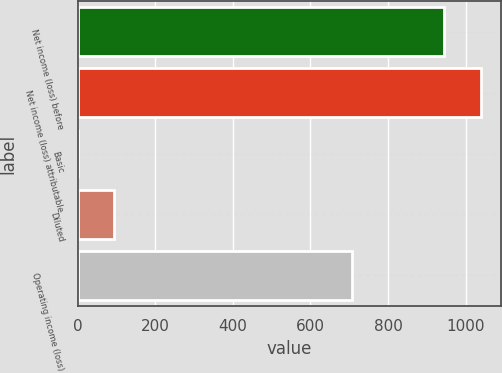<chart> <loc_0><loc_0><loc_500><loc_500><bar_chart><fcel>Net income (loss) before<fcel>Net income (loss) attributable<fcel>Basic<fcel>Diluted<fcel>Operating income (loss)<nl><fcel>945<fcel>1039.5<fcel>0.01<fcel>94.51<fcel>708<nl></chart> 